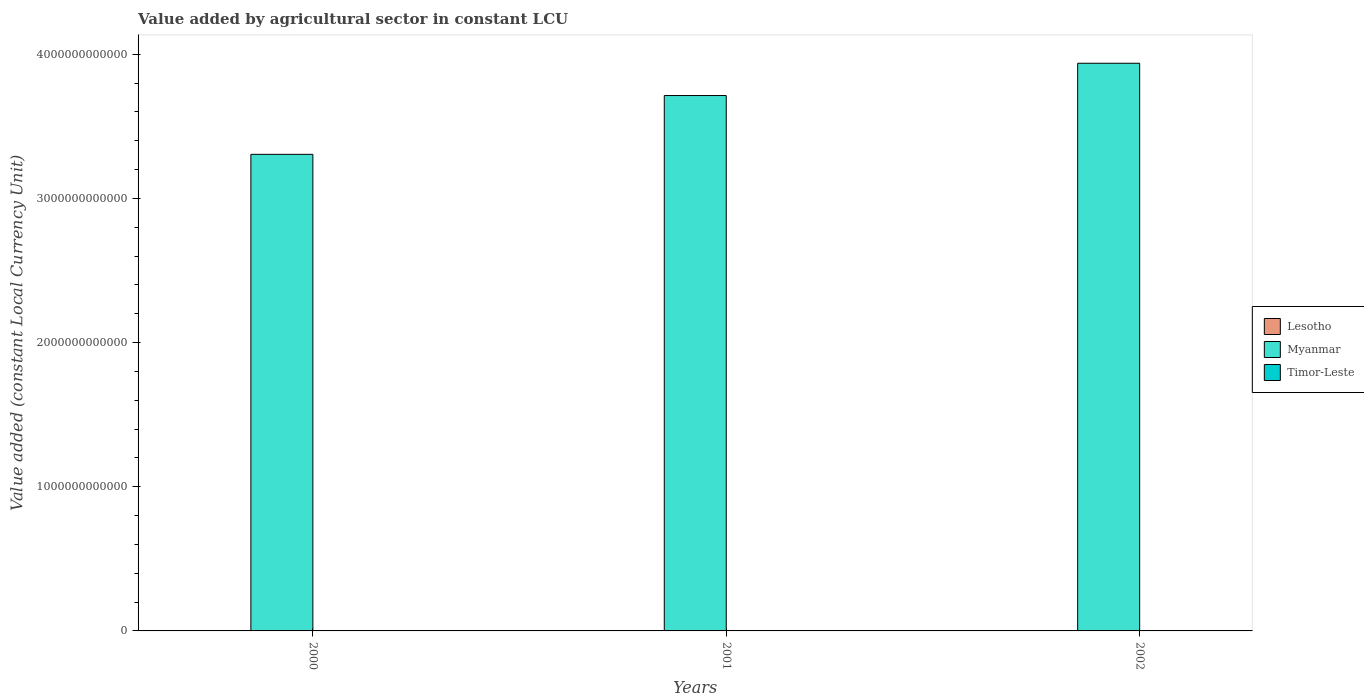How many different coloured bars are there?
Provide a short and direct response. 3. Are the number of bars on each tick of the X-axis equal?
Offer a terse response. Yes. How many bars are there on the 2nd tick from the right?
Provide a short and direct response. 3. What is the label of the 1st group of bars from the left?
Your response must be concise. 2000. What is the value added by agricultural sector in Lesotho in 2001?
Offer a very short reply. 9.70e+08. Across all years, what is the maximum value added by agricultural sector in Timor-Leste?
Your response must be concise. 1.66e+08. Across all years, what is the minimum value added by agricultural sector in Lesotho?
Keep it short and to the point. 6.85e+08. In which year was the value added by agricultural sector in Timor-Leste maximum?
Give a very brief answer. 2002. In which year was the value added by agricultural sector in Myanmar minimum?
Your answer should be compact. 2000. What is the total value added by agricultural sector in Myanmar in the graph?
Ensure brevity in your answer.  1.10e+13. What is the difference between the value added by agricultural sector in Timor-Leste in 2000 and that in 2002?
Your response must be concise. -1.10e+07. What is the difference between the value added by agricultural sector in Lesotho in 2000 and the value added by agricultural sector in Timor-Leste in 2002?
Ensure brevity in your answer.  6.93e+08. What is the average value added by agricultural sector in Timor-Leste per year?
Ensure brevity in your answer.  1.59e+08. In the year 2001, what is the difference between the value added by agricultural sector in Lesotho and value added by agricultural sector in Myanmar?
Your answer should be very brief. -3.71e+12. In how many years, is the value added by agricultural sector in Lesotho greater than 2200000000000 LCU?
Make the answer very short. 0. What is the ratio of the value added by agricultural sector in Lesotho in 2000 to that in 2001?
Ensure brevity in your answer.  0.89. Is the value added by agricultural sector in Lesotho in 2000 less than that in 2001?
Make the answer very short. Yes. Is the difference between the value added by agricultural sector in Lesotho in 2001 and 2002 greater than the difference between the value added by agricultural sector in Myanmar in 2001 and 2002?
Give a very brief answer. Yes. What is the difference between the highest and the second highest value added by agricultural sector in Lesotho?
Keep it short and to the point. 1.11e+08. What is the difference between the highest and the lowest value added by agricultural sector in Lesotho?
Your response must be concise. 2.85e+08. In how many years, is the value added by agricultural sector in Myanmar greater than the average value added by agricultural sector in Myanmar taken over all years?
Give a very brief answer. 2. Is the sum of the value added by agricultural sector in Lesotho in 2000 and 2001 greater than the maximum value added by agricultural sector in Myanmar across all years?
Offer a terse response. No. What does the 1st bar from the left in 2002 represents?
Ensure brevity in your answer.  Lesotho. What does the 1st bar from the right in 2002 represents?
Offer a terse response. Timor-Leste. How many bars are there?
Keep it short and to the point. 9. Are all the bars in the graph horizontal?
Your response must be concise. No. How many years are there in the graph?
Offer a very short reply. 3. What is the difference between two consecutive major ticks on the Y-axis?
Ensure brevity in your answer.  1.00e+12. Does the graph contain any zero values?
Give a very brief answer. No. Does the graph contain grids?
Keep it short and to the point. No. Where does the legend appear in the graph?
Offer a terse response. Center right. What is the title of the graph?
Your answer should be compact. Value added by agricultural sector in constant LCU. What is the label or title of the Y-axis?
Make the answer very short. Value added (constant Local Currency Unit). What is the Value added (constant Local Currency Unit) in Lesotho in 2000?
Your answer should be compact. 8.59e+08. What is the Value added (constant Local Currency Unit) of Myanmar in 2000?
Ensure brevity in your answer.  3.31e+12. What is the Value added (constant Local Currency Unit) of Timor-Leste in 2000?
Keep it short and to the point. 1.55e+08. What is the Value added (constant Local Currency Unit) of Lesotho in 2001?
Provide a succinct answer. 9.70e+08. What is the Value added (constant Local Currency Unit) of Myanmar in 2001?
Offer a terse response. 3.71e+12. What is the Value added (constant Local Currency Unit) of Timor-Leste in 2001?
Keep it short and to the point. 1.55e+08. What is the Value added (constant Local Currency Unit) of Lesotho in 2002?
Your answer should be compact. 6.85e+08. What is the Value added (constant Local Currency Unit) of Myanmar in 2002?
Your response must be concise. 3.94e+12. What is the Value added (constant Local Currency Unit) of Timor-Leste in 2002?
Keep it short and to the point. 1.66e+08. Across all years, what is the maximum Value added (constant Local Currency Unit) in Lesotho?
Provide a succinct answer. 9.70e+08. Across all years, what is the maximum Value added (constant Local Currency Unit) in Myanmar?
Keep it short and to the point. 3.94e+12. Across all years, what is the maximum Value added (constant Local Currency Unit) in Timor-Leste?
Your answer should be compact. 1.66e+08. Across all years, what is the minimum Value added (constant Local Currency Unit) in Lesotho?
Your answer should be very brief. 6.85e+08. Across all years, what is the minimum Value added (constant Local Currency Unit) of Myanmar?
Keep it short and to the point. 3.31e+12. Across all years, what is the minimum Value added (constant Local Currency Unit) in Timor-Leste?
Provide a succinct answer. 1.55e+08. What is the total Value added (constant Local Currency Unit) of Lesotho in the graph?
Offer a terse response. 2.51e+09. What is the total Value added (constant Local Currency Unit) of Myanmar in the graph?
Make the answer very short. 1.10e+13. What is the total Value added (constant Local Currency Unit) of Timor-Leste in the graph?
Your response must be concise. 4.76e+08. What is the difference between the Value added (constant Local Currency Unit) of Lesotho in 2000 and that in 2001?
Your answer should be very brief. -1.11e+08. What is the difference between the Value added (constant Local Currency Unit) in Myanmar in 2000 and that in 2001?
Your answer should be very brief. -4.08e+11. What is the difference between the Value added (constant Local Currency Unit) in Timor-Leste in 2000 and that in 2001?
Keep it short and to the point. 0. What is the difference between the Value added (constant Local Currency Unit) in Lesotho in 2000 and that in 2002?
Make the answer very short. 1.74e+08. What is the difference between the Value added (constant Local Currency Unit) of Myanmar in 2000 and that in 2002?
Provide a short and direct response. -6.32e+11. What is the difference between the Value added (constant Local Currency Unit) in Timor-Leste in 2000 and that in 2002?
Make the answer very short. -1.10e+07. What is the difference between the Value added (constant Local Currency Unit) of Lesotho in 2001 and that in 2002?
Keep it short and to the point. 2.85e+08. What is the difference between the Value added (constant Local Currency Unit) of Myanmar in 2001 and that in 2002?
Offer a terse response. -2.24e+11. What is the difference between the Value added (constant Local Currency Unit) of Timor-Leste in 2001 and that in 2002?
Your response must be concise. -1.10e+07. What is the difference between the Value added (constant Local Currency Unit) of Lesotho in 2000 and the Value added (constant Local Currency Unit) of Myanmar in 2001?
Provide a succinct answer. -3.71e+12. What is the difference between the Value added (constant Local Currency Unit) in Lesotho in 2000 and the Value added (constant Local Currency Unit) in Timor-Leste in 2001?
Offer a terse response. 7.04e+08. What is the difference between the Value added (constant Local Currency Unit) of Myanmar in 2000 and the Value added (constant Local Currency Unit) of Timor-Leste in 2001?
Make the answer very short. 3.31e+12. What is the difference between the Value added (constant Local Currency Unit) of Lesotho in 2000 and the Value added (constant Local Currency Unit) of Myanmar in 2002?
Offer a terse response. -3.94e+12. What is the difference between the Value added (constant Local Currency Unit) of Lesotho in 2000 and the Value added (constant Local Currency Unit) of Timor-Leste in 2002?
Your answer should be compact. 6.93e+08. What is the difference between the Value added (constant Local Currency Unit) of Myanmar in 2000 and the Value added (constant Local Currency Unit) of Timor-Leste in 2002?
Your answer should be compact. 3.31e+12. What is the difference between the Value added (constant Local Currency Unit) of Lesotho in 2001 and the Value added (constant Local Currency Unit) of Myanmar in 2002?
Offer a very short reply. -3.94e+12. What is the difference between the Value added (constant Local Currency Unit) of Lesotho in 2001 and the Value added (constant Local Currency Unit) of Timor-Leste in 2002?
Ensure brevity in your answer.  8.04e+08. What is the difference between the Value added (constant Local Currency Unit) of Myanmar in 2001 and the Value added (constant Local Currency Unit) of Timor-Leste in 2002?
Provide a succinct answer. 3.71e+12. What is the average Value added (constant Local Currency Unit) of Lesotho per year?
Your answer should be very brief. 8.38e+08. What is the average Value added (constant Local Currency Unit) of Myanmar per year?
Provide a succinct answer. 3.65e+12. What is the average Value added (constant Local Currency Unit) in Timor-Leste per year?
Make the answer very short. 1.59e+08. In the year 2000, what is the difference between the Value added (constant Local Currency Unit) in Lesotho and Value added (constant Local Currency Unit) in Myanmar?
Offer a very short reply. -3.31e+12. In the year 2000, what is the difference between the Value added (constant Local Currency Unit) of Lesotho and Value added (constant Local Currency Unit) of Timor-Leste?
Your answer should be very brief. 7.04e+08. In the year 2000, what is the difference between the Value added (constant Local Currency Unit) of Myanmar and Value added (constant Local Currency Unit) of Timor-Leste?
Make the answer very short. 3.31e+12. In the year 2001, what is the difference between the Value added (constant Local Currency Unit) of Lesotho and Value added (constant Local Currency Unit) of Myanmar?
Provide a short and direct response. -3.71e+12. In the year 2001, what is the difference between the Value added (constant Local Currency Unit) of Lesotho and Value added (constant Local Currency Unit) of Timor-Leste?
Offer a terse response. 8.15e+08. In the year 2001, what is the difference between the Value added (constant Local Currency Unit) of Myanmar and Value added (constant Local Currency Unit) of Timor-Leste?
Your answer should be very brief. 3.71e+12. In the year 2002, what is the difference between the Value added (constant Local Currency Unit) in Lesotho and Value added (constant Local Currency Unit) in Myanmar?
Provide a short and direct response. -3.94e+12. In the year 2002, what is the difference between the Value added (constant Local Currency Unit) of Lesotho and Value added (constant Local Currency Unit) of Timor-Leste?
Your answer should be very brief. 5.19e+08. In the year 2002, what is the difference between the Value added (constant Local Currency Unit) of Myanmar and Value added (constant Local Currency Unit) of Timor-Leste?
Provide a succinct answer. 3.94e+12. What is the ratio of the Value added (constant Local Currency Unit) in Lesotho in 2000 to that in 2001?
Offer a very short reply. 0.89. What is the ratio of the Value added (constant Local Currency Unit) in Myanmar in 2000 to that in 2001?
Provide a short and direct response. 0.89. What is the ratio of the Value added (constant Local Currency Unit) of Timor-Leste in 2000 to that in 2001?
Make the answer very short. 1. What is the ratio of the Value added (constant Local Currency Unit) in Lesotho in 2000 to that in 2002?
Provide a succinct answer. 1.25. What is the ratio of the Value added (constant Local Currency Unit) in Myanmar in 2000 to that in 2002?
Offer a terse response. 0.84. What is the ratio of the Value added (constant Local Currency Unit) in Timor-Leste in 2000 to that in 2002?
Offer a terse response. 0.93. What is the ratio of the Value added (constant Local Currency Unit) of Lesotho in 2001 to that in 2002?
Your answer should be compact. 1.42. What is the ratio of the Value added (constant Local Currency Unit) of Myanmar in 2001 to that in 2002?
Your answer should be very brief. 0.94. What is the ratio of the Value added (constant Local Currency Unit) in Timor-Leste in 2001 to that in 2002?
Offer a terse response. 0.93. What is the difference between the highest and the second highest Value added (constant Local Currency Unit) of Lesotho?
Make the answer very short. 1.11e+08. What is the difference between the highest and the second highest Value added (constant Local Currency Unit) in Myanmar?
Offer a terse response. 2.24e+11. What is the difference between the highest and the second highest Value added (constant Local Currency Unit) of Timor-Leste?
Provide a short and direct response. 1.10e+07. What is the difference between the highest and the lowest Value added (constant Local Currency Unit) of Lesotho?
Make the answer very short. 2.85e+08. What is the difference between the highest and the lowest Value added (constant Local Currency Unit) of Myanmar?
Provide a short and direct response. 6.32e+11. What is the difference between the highest and the lowest Value added (constant Local Currency Unit) in Timor-Leste?
Keep it short and to the point. 1.10e+07. 